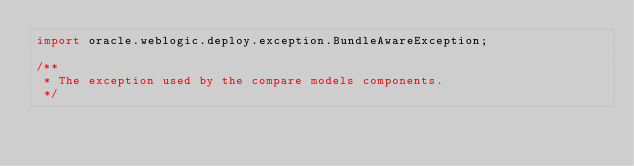<code> <loc_0><loc_0><loc_500><loc_500><_Java_>import oracle.weblogic.deploy.exception.BundleAwareException;

/**
 * The exception used by the compare models components.
 */</code> 